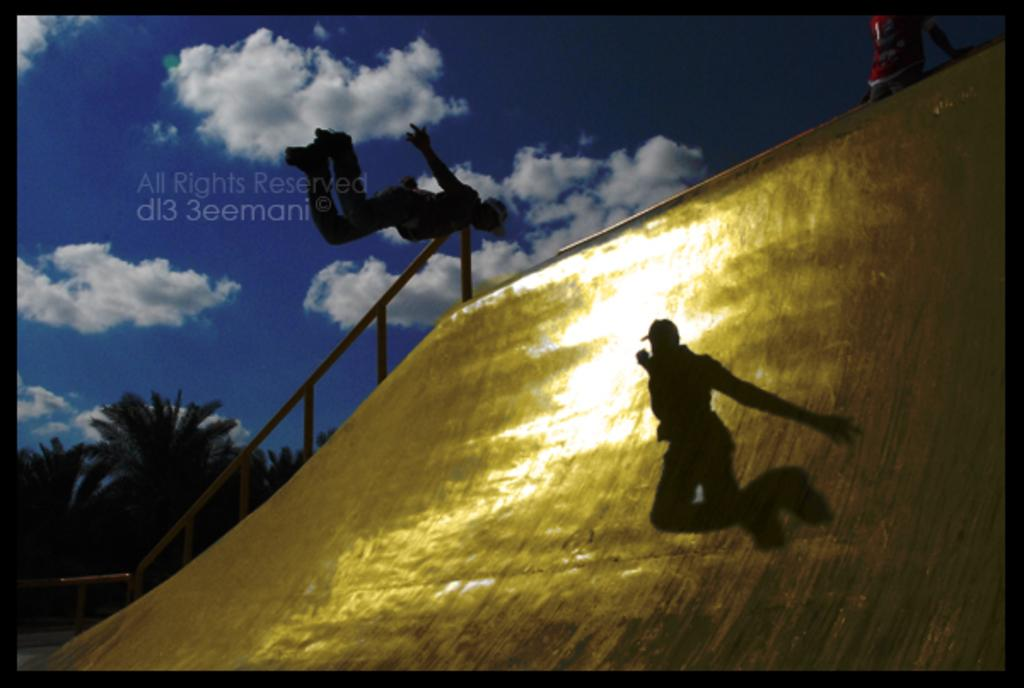What is the main feature in the image? There is a slide in the image. Can you describe the people in the image? There are people in the image. What can be seen on the right side of the image? There are objects on the right side of the image. What safety feature is visible in the image? There is railing visible in the image. What type of natural environment is present in the image? Trees are present in the image. What is visible in the background of the image? The sky is visible in the image, and clouds are present in the sky. Is there any text in the image? Yes, there is some text in the image. What type of songs can be heard playing in the background of the image? There is no audio or indication of music in the image, so it is not possible to determine what songs might be heard. 